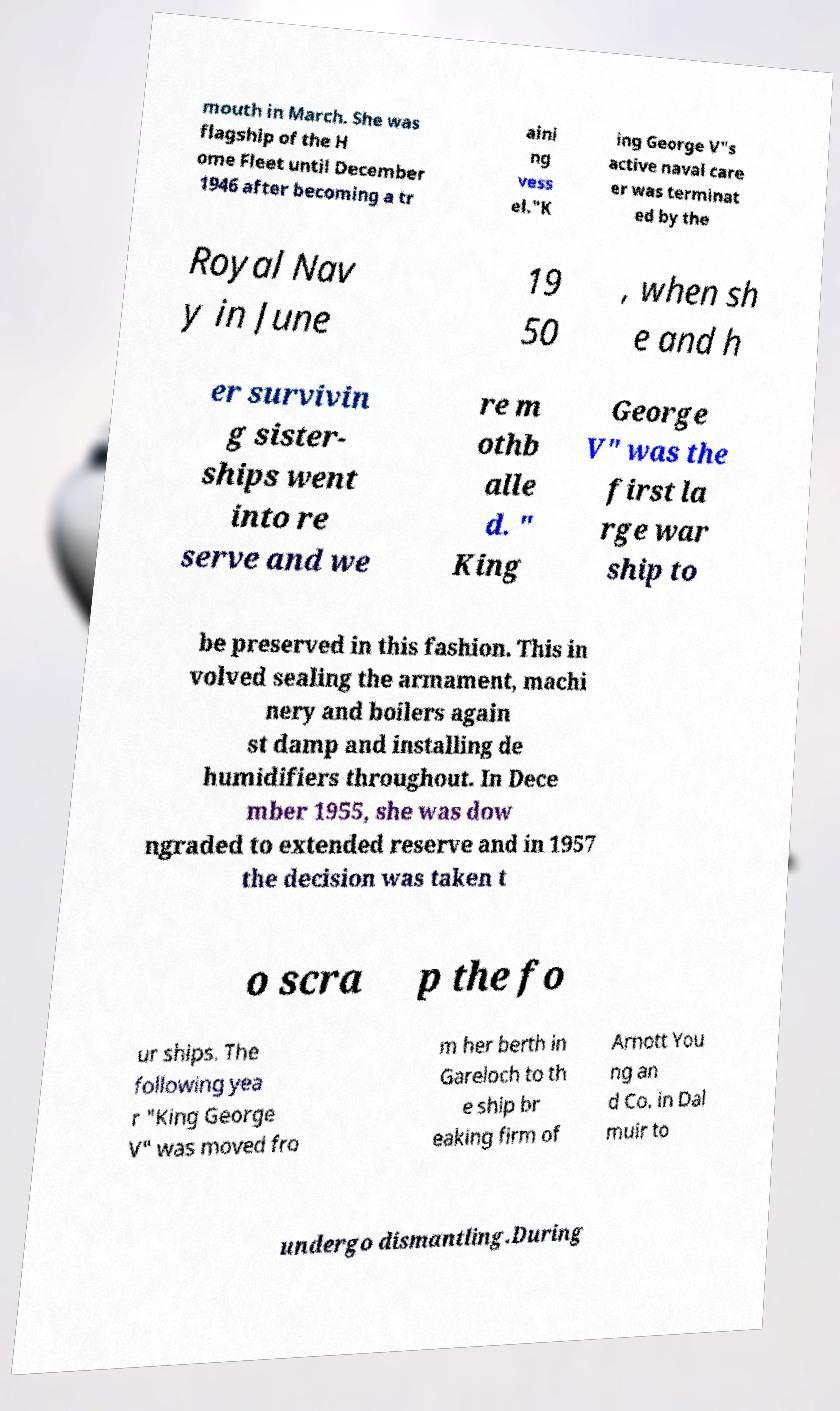Could you assist in decoding the text presented in this image and type it out clearly? mouth in March. She was flagship of the H ome Fleet until December 1946 after becoming a tr aini ng vess el."K ing George V"s active naval care er was terminat ed by the Royal Nav y in June 19 50 , when sh e and h er survivin g sister- ships went into re serve and we re m othb alle d. " King George V" was the first la rge war ship to be preserved in this fashion. This in volved sealing the armament, machi nery and boilers again st damp and installing de humidifiers throughout. In Dece mber 1955, she was dow ngraded to extended reserve and in 1957 the decision was taken t o scra p the fo ur ships. The following yea r "King George V" was moved fro m her berth in Gareloch to th e ship br eaking firm of Arnott You ng an d Co. in Dal muir to undergo dismantling.During 